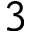<formula> <loc_0><loc_0><loc_500><loc_500>3</formula> 